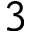<formula> <loc_0><loc_0><loc_500><loc_500>3</formula> 